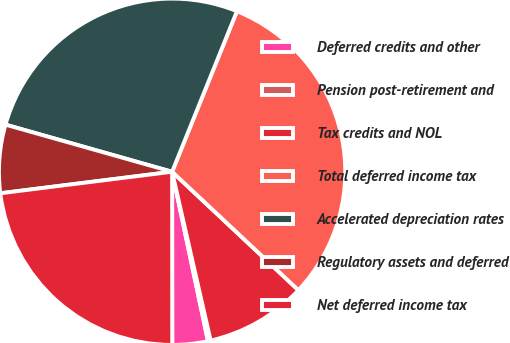<chart> <loc_0><loc_0><loc_500><loc_500><pie_chart><fcel>Deferred credits and other<fcel>Pension post-retirement and<fcel>Tax credits and NOL<fcel>Total deferred income tax<fcel>Accelerated depreciation rates<fcel>Regulatory assets and deferred<fcel>Net deferred income tax<nl><fcel>3.31%<fcel>0.25%<fcel>9.44%<fcel>30.88%<fcel>26.72%<fcel>6.37%<fcel>23.03%<nl></chart> 